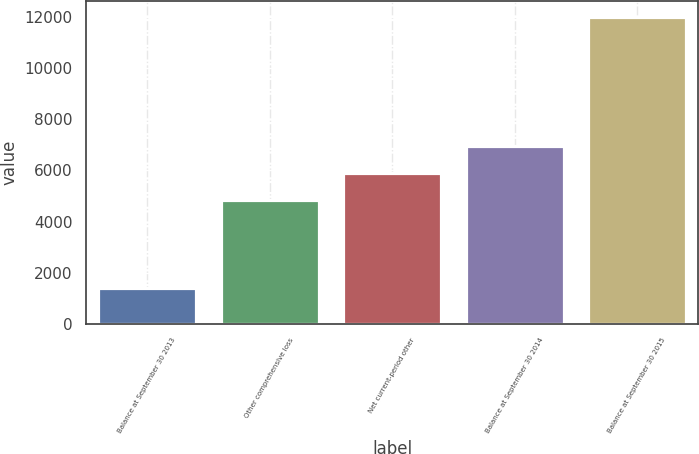<chart> <loc_0><loc_0><loc_500><loc_500><bar_chart><fcel>Balance at September 30 2013<fcel>Other comprehensive loss<fcel>Net current-period other<fcel>Balance at September 30 2014<fcel>Balance at September 30 2015<nl><fcel>1391<fcel>4836<fcel>5898.2<fcel>6960.4<fcel>12013<nl></chart> 